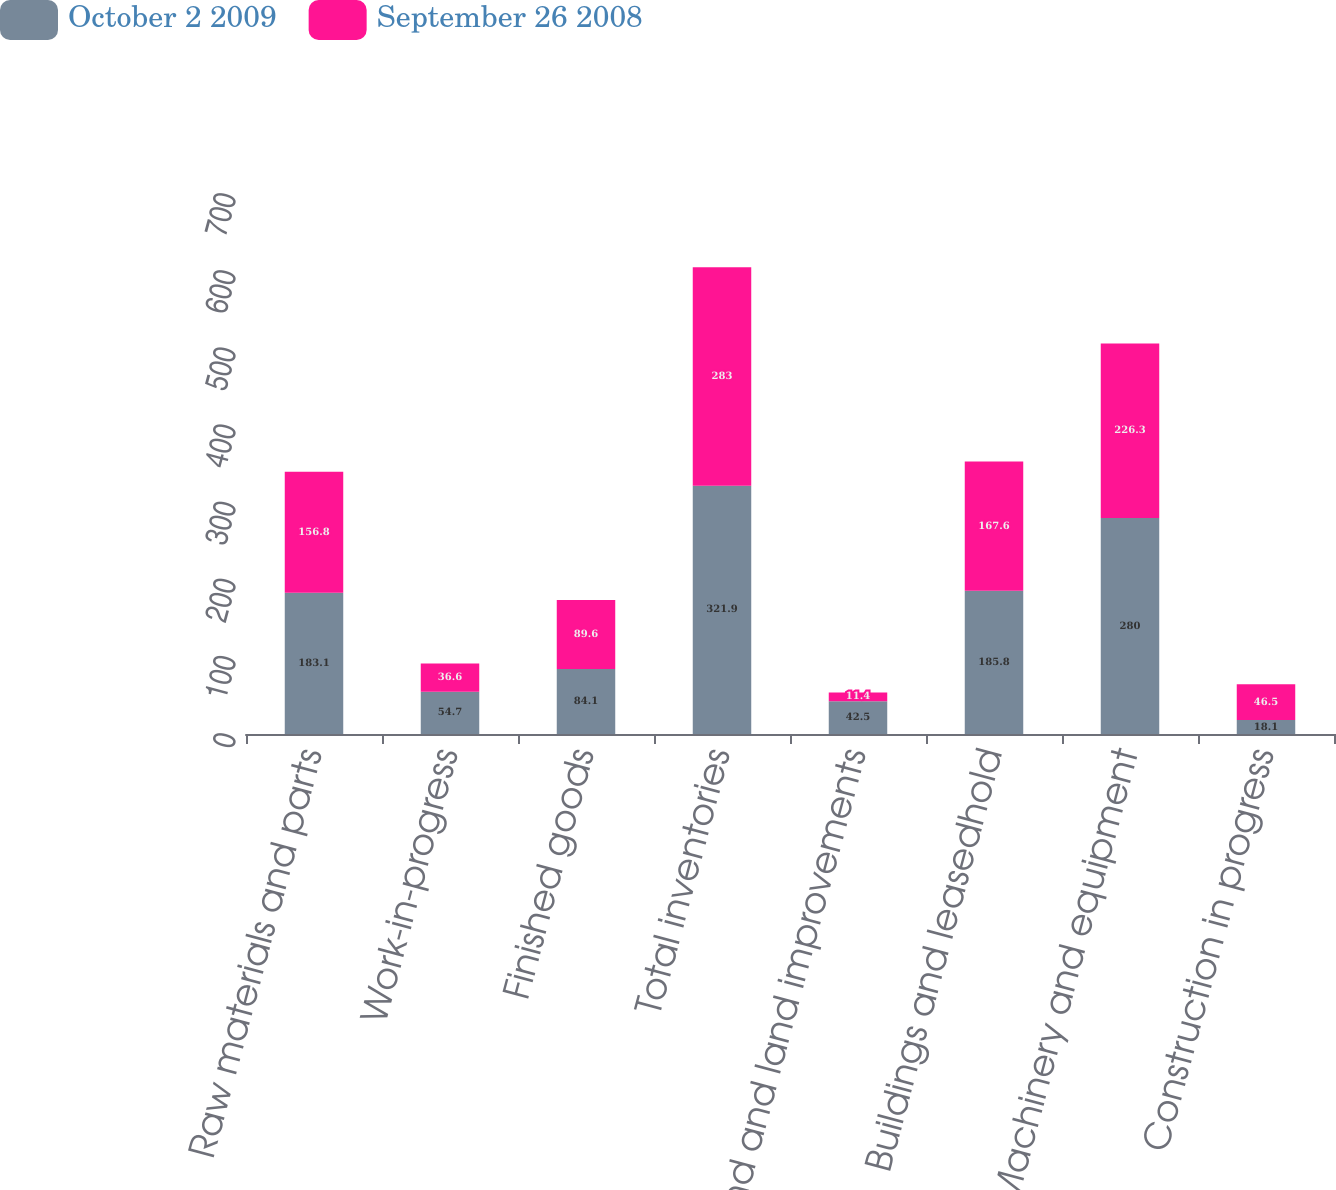Convert chart to OTSL. <chart><loc_0><loc_0><loc_500><loc_500><stacked_bar_chart><ecel><fcel>Raw materials and parts<fcel>Work-in-progress<fcel>Finished goods<fcel>Total inventories<fcel>Land and land improvements<fcel>Buildings and leasedhold<fcel>Machinery and equipment<fcel>Construction in progress<nl><fcel>October 2 2009<fcel>183.1<fcel>54.7<fcel>84.1<fcel>321.9<fcel>42.5<fcel>185.8<fcel>280<fcel>18.1<nl><fcel>September 26 2008<fcel>156.8<fcel>36.6<fcel>89.6<fcel>283<fcel>11.4<fcel>167.6<fcel>226.3<fcel>46.5<nl></chart> 